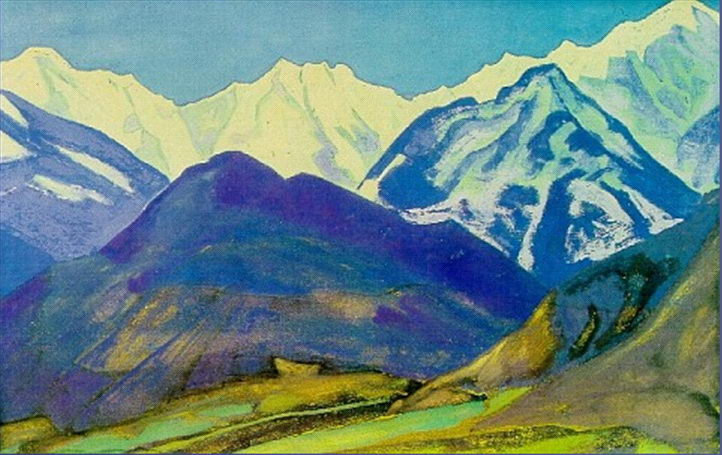Analyze the image in a comprehensive and detailed manner. The image showcases an awe-inspiring mountain landscape that appears to be rendered in a post-impressionist style. Dominating the picture are the grand mountains painted in a rich blend of blues, greens, and purples, their snow-capped peaks gently fading into the horizon. In the foreground, a lush valley can be seen, highlighted by a calm, reflective body of water. The artist's use of vibrant and varied colors provides a dynamic sense of depth and distance, bringing the scene to life. The loose, expressive brushstrokes and bold color choices are hallmarks of the post-impressionist art form, suggesting a strong influence of emotional and sensory experience. This composition's vivid palette and engaging structure evoke a serene and timeless natural beauty that invites viewers to linger in its tranquil embrace. 